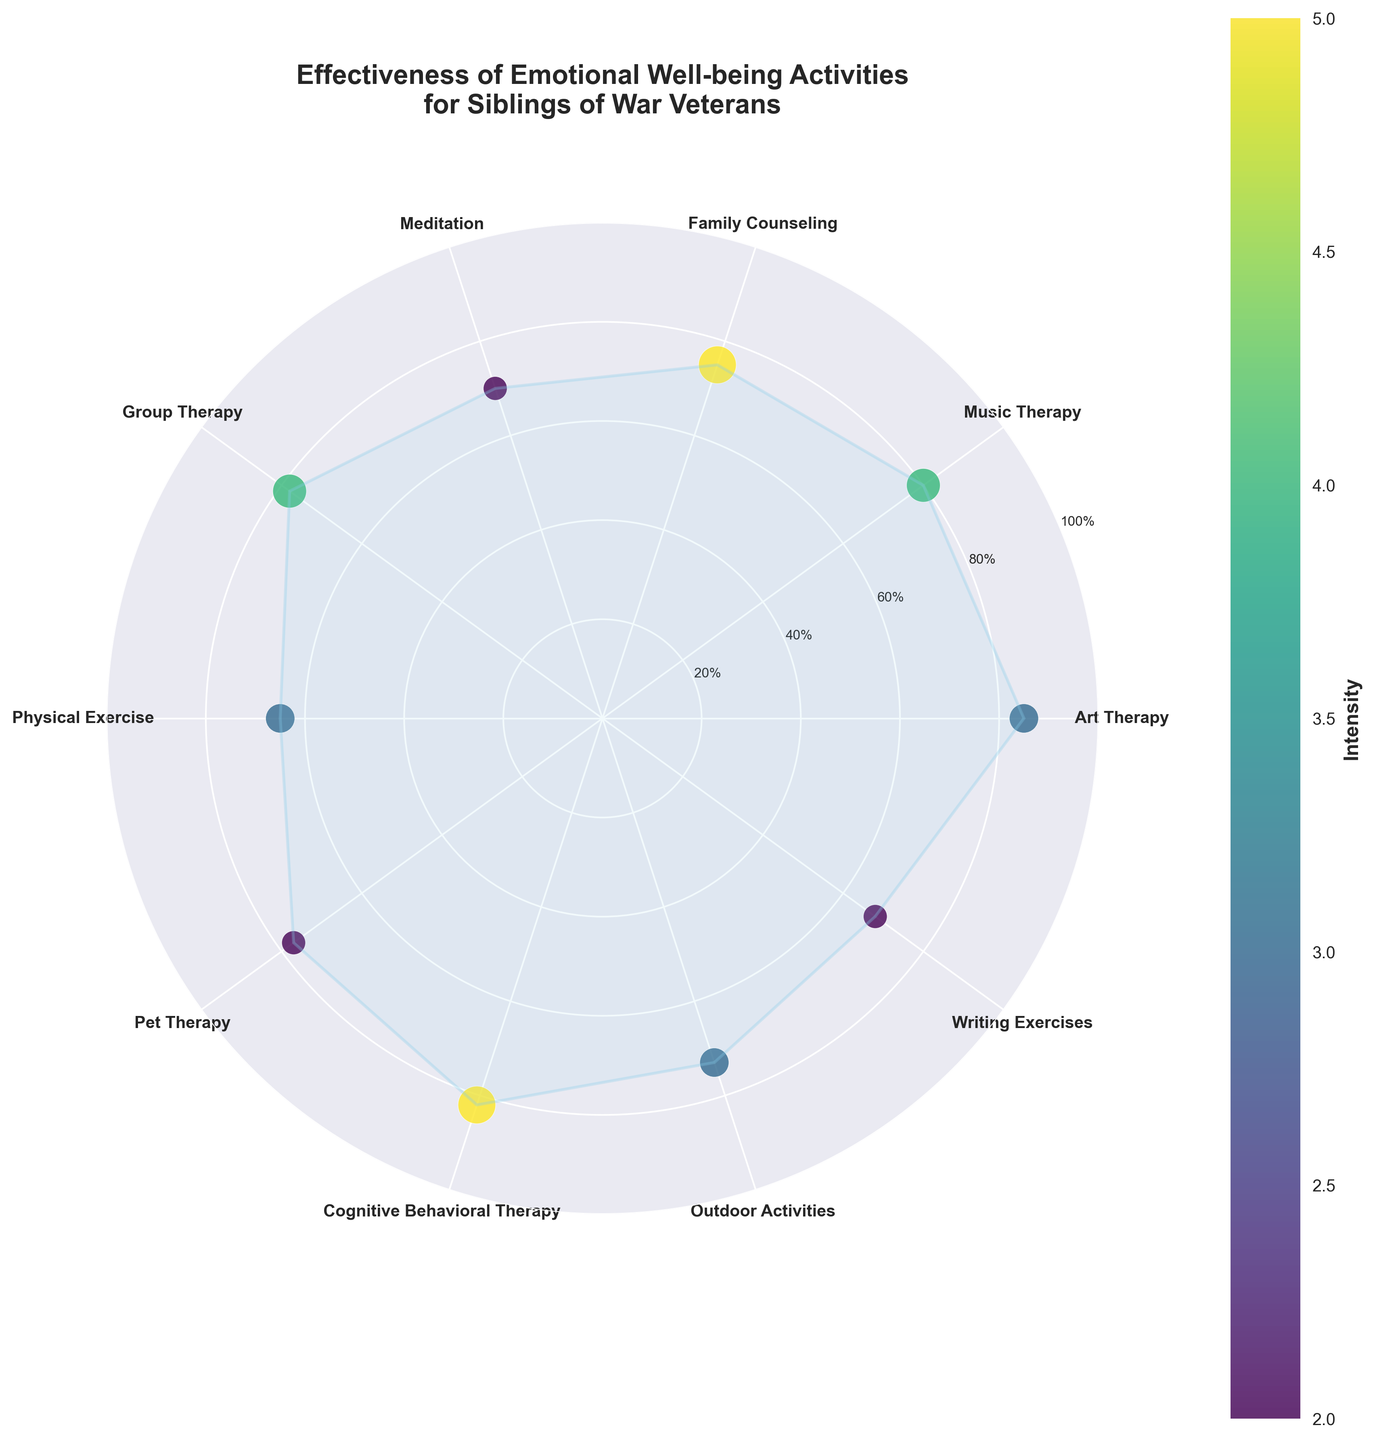What is the title of the chart? The title is located at the top of the chart and is usually in a larger font.
Answer: Effectiveness of Emotional Well-being Activities for Siblings of War Veterans How many activities are represented on the chart? Each activity is labeled around the perimeter of the polar plot. Count these labels to determine the number of activities.
Answer: 10 Which activity is represented by the data point with the highest effectiveness? Check the radial axis and find the data point that is farthest from the center. Look at the corresponding label on the circumference.
Answer: Art Therapy What is the effectiveness of Meditation? Locate the corresponding label for Meditation, then trace inward to read the value on the radial axis.
Answer: 70% Which activities have an intensity level of 5? Identify the data points with the largest marker size, then match these points to their respective labels.
Answer: Family Counseling, Cognitive Behavioral Therapy What is the range of effectiveness percentages for all activities? Identify the smallest and largest effectiveness values from the data points on the radial axis. Subtract the smallest from the largest to find the range.
Answer: 65% to 85% How many activities have an effectiveness of 75% or higher? Count the data points that lie on or beyond the 75% mark on the radial axis.
Answer: 6 Compare the effectiveness of Pet Therapy and Music Therapy. Which one is higher? Locate the data points for both activities and compare their distances from the center. The one farther out is higher.
Answer: Music Therapy What is the average effectiveness of Group Therapy, Family Counseling, and Cognitive Behavioral Therapy? Add the effectiveness values of these activities and divide by the number of activities to find the average.
Answer: (78% + 75% + 82%) / 3 = 78.33% Which activities have both a low intensity (2 or below) and relatively high effectiveness (70% or above)? Find data points with smaller markers and check their effectiveness values to see if they meet both criteria.
Answer: Meditation, Pet Therapy 